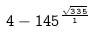<formula> <loc_0><loc_0><loc_500><loc_500>4 - 1 4 5 ^ { \frac { \sqrt { 3 3 5 } } { 1 } }</formula> 